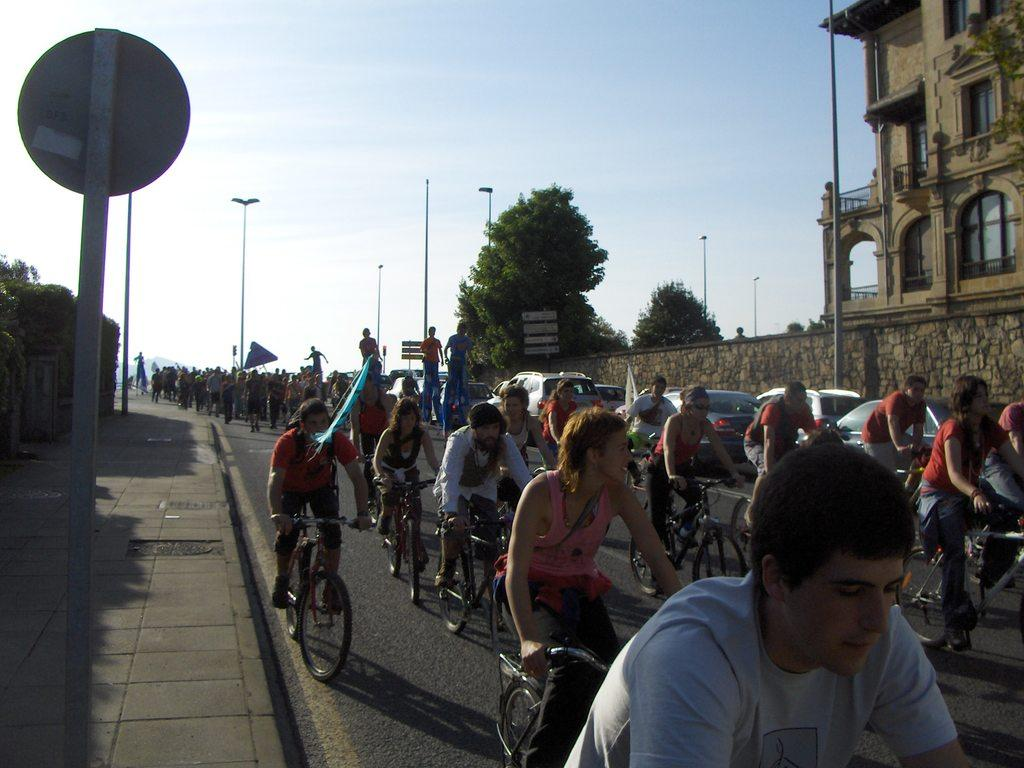What are the people in the image doing? The people in the image are riding bicycles on the roads. What type of vegetation can be seen in the image? Trees are visible in the image. What is the condition of the sky in the image? The sky is clear in the image. What objects are present in the image that might be used for illumination? There are street lights present in the image. What type of structure can be seen in the image? There is at least one building in the image. What type of iron waste can be seen in the image? There is no iron waste present in the image. 